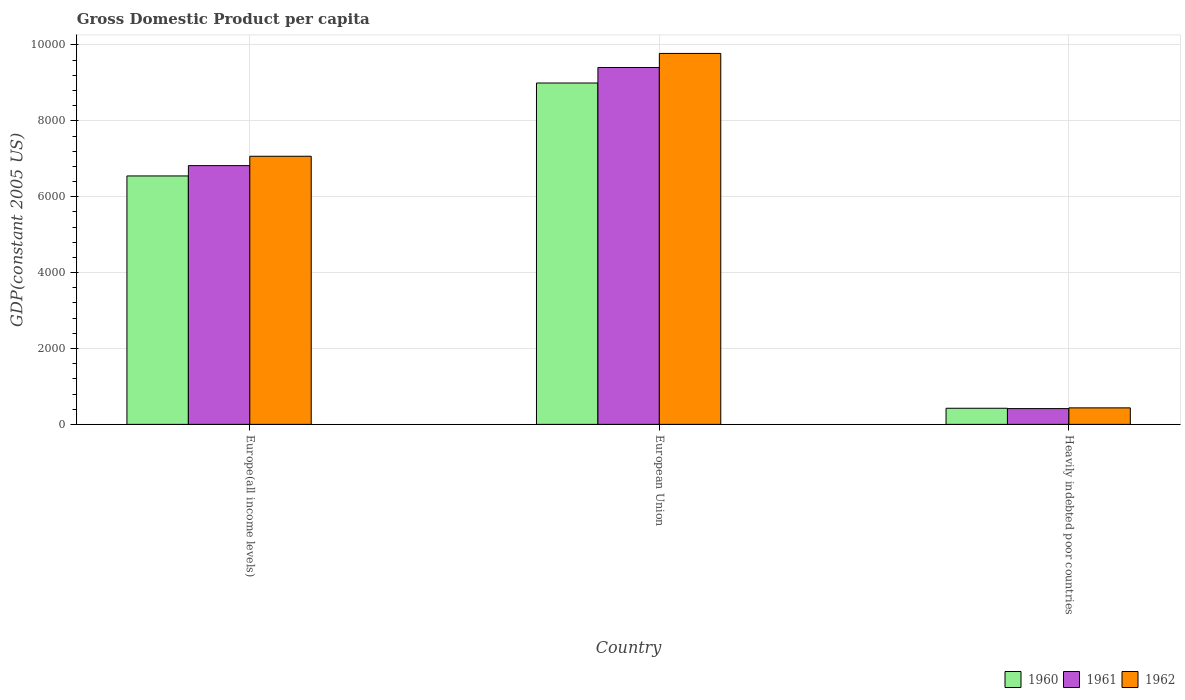Are the number of bars per tick equal to the number of legend labels?
Provide a succinct answer. Yes. Are the number of bars on each tick of the X-axis equal?
Offer a terse response. Yes. How many bars are there on the 1st tick from the left?
Keep it short and to the point. 3. How many bars are there on the 1st tick from the right?
Your response must be concise. 3. What is the label of the 2nd group of bars from the left?
Provide a succinct answer. European Union. In how many cases, is the number of bars for a given country not equal to the number of legend labels?
Offer a terse response. 0. What is the GDP per capita in 1961 in Heavily indebted poor countries?
Keep it short and to the point. 415.63. Across all countries, what is the maximum GDP per capita in 1962?
Offer a very short reply. 9777.3. Across all countries, what is the minimum GDP per capita in 1962?
Offer a very short reply. 435.15. In which country was the GDP per capita in 1962 maximum?
Your answer should be compact. European Union. In which country was the GDP per capita in 1960 minimum?
Offer a very short reply. Heavily indebted poor countries. What is the total GDP per capita in 1962 in the graph?
Provide a short and direct response. 1.73e+04. What is the difference between the GDP per capita in 1960 in European Union and that in Heavily indebted poor countries?
Your response must be concise. 8572.57. What is the difference between the GDP per capita in 1961 in Europe(all income levels) and the GDP per capita in 1960 in European Union?
Give a very brief answer. -2177.67. What is the average GDP per capita in 1960 per country?
Keep it short and to the point. 5323.44. What is the difference between the GDP per capita of/in 1960 and GDP per capita of/in 1961 in European Union?
Give a very brief answer. -408.81. In how many countries, is the GDP per capita in 1961 greater than 400 US$?
Offer a very short reply. 3. What is the ratio of the GDP per capita in 1962 in Europe(all income levels) to that in Heavily indebted poor countries?
Your answer should be very brief. 16.24. Is the GDP per capita in 1960 in Europe(all income levels) less than that in Heavily indebted poor countries?
Your answer should be very brief. No. Is the difference between the GDP per capita in 1960 in European Union and Heavily indebted poor countries greater than the difference between the GDP per capita in 1961 in European Union and Heavily indebted poor countries?
Your response must be concise. No. What is the difference between the highest and the second highest GDP per capita in 1961?
Give a very brief answer. -2586.48. What is the difference between the highest and the lowest GDP per capita in 1962?
Your answer should be very brief. 9342.14. In how many countries, is the GDP per capita in 1961 greater than the average GDP per capita in 1961 taken over all countries?
Keep it short and to the point. 2. What does the 2nd bar from the left in European Union represents?
Offer a terse response. 1961. What does the 3rd bar from the right in Europe(all income levels) represents?
Ensure brevity in your answer.  1960. Are the values on the major ticks of Y-axis written in scientific E-notation?
Offer a very short reply. No. Does the graph contain any zero values?
Your answer should be compact. No. How many legend labels are there?
Ensure brevity in your answer.  3. How are the legend labels stacked?
Provide a short and direct response. Horizontal. What is the title of the graph?
Keep it short and to the point. Gross Domestic Product per capita. Does "2000" appear as one of the legend labels in the graph?
Give a very brief answer. No. What is the label or title of the Y-axis?
Your answer should be very brief. GDP(constant 2005 US). What is the GDP(constant 2005 US) of 1960 in Europe(all income levels)?
Your response must be concise. 6547.96. What is the GDP(constant 2005 US) in 1961 in Europe(all income levels)?
Your answer should be very brief. 6819.79. What is the GDP(constant 2005 US) of 1962 in Europe(all income levels)?
Your answer should be compact. 7066.73. What is the GDP(constant 2005 US) in 1960 in European Union?
Give a very brief answer. 8997.47. What is the GDP(constant 2005 US) of 1961 in European Union?
Your response must be concise. 9406.28. What is the GDP(constant 2005 US) in 1962 in European Union?
Provide a succinct answer. 9777.3. What is the GDP(constant 2005 US) in 1960 in Heavily indebted poor countries?
Offer a terse response. 424.89. What is the GDP(constant 2005 US) of 1961 in Heavily indebted poor countries?
Keep it short and to the point. 415.63. What is the GDP(constant 2005 US) of 1962 in Heavily indebted poor countries?
Ensure brevity in your answer.  435.15. Across all countries, what is the maximum GDP(constant 2005 US) of 1960?
Provide a short and direct response. 8997.47. Across all countries, what is the maximum GDP(constant 2005 US) of 1961?
Provide a succinct answer. 9406.28. Across all countries, what is the maximum GDP(constant 2005 US) in 1962?
Your response must be concise. 9777.3. Across all countries, what is the minimum GDP(constant 2005 US) in 1960?
Offer a terse response. 424.89. Across all countries, what is the minimum GDP(constant 2005 US) in 1961?
Provide a succinct answer. 415.63. Across all countries, what is the minimum GDP(constant 2005 US) of 1962?
Offer a very short reply. 435.15. What is the total GDP(constant 2005 US) in 1960 in the graph?
Your answer should be compact. 1.60e+04. What is the total GDP(constant 2005 US) in 1961 in the graph?
Make the answer very short. 1.66e+04. What is the total GDP(constant 2005 US) of 1962 in the graph?
Give a very brief answer. 1.73e+04. What is the difference between the GDP(constant 2005 US) of 1960 in Europe(all income levels) and that in European Union?
Make the answer very short. -2449.5. What is the difference between the GDP(constant 2005 US) of 1961 in Europe(all income levels) and that in European Union?
Your answer should be compact. -2586.48. What is the difference between the GDP(constant 2005 US) in 1962 in Europe(all income levels) and that in European Union?
Your answer should be compact. -2710.56. What is the difference between the GDP(constant 2005 US) of 1960 in Europe(all income levels) and that in Heavily indebted poor countries?
Provide a short and direct response. 6123.07. What is the difference between the GDP(constant 2005 US) in 1961 in Europe(all income levels) and that in Heavily indebted poor countries?
Your answer should be very brief. 6404.17. What is the difference between the GDP(constant 2005 US) in 1962 in Europe(all income levels) and that in Heavily indebted poor countries?
Your answer should be compact. 6631.58. What is the difference between the GDP(constant 2005 US) of 1960 in European Union and that in Heavily indebted poor countries?
Provide a succinct answer. 8572.57. What is the difference between the GDP(constant 2005 US) of 1961 in European Union and that in Heavily indebted poor countries?
Provide a succinct answer. 8990.65. What is the difference between the GDP(constant 2005 US) in 1962 in European Union and that in Heavily indebted poor countries?
Provide a succinct answer. 9342.14. What is the difference between the GDP(constant 2005 US) in 1960 in Europe(all income levels) and the GDP(constant 2005 US) in 1961 in European Union?
Your response must be concise. -2858.31. What is the difference between the GDP(constant 2005 US) in 1960 in Europe(all income levels) and the GDP(constant 2005 US) in 1962 in European Union?
Provide a short and direct response. -3229.33. What is the difference between the GDP(constant 2005 US) of 1961 in Europe(all income levels) and the GDP(constant 2005 US) of 1962 in European Union?
Ensure brevity in your answer.  -2957.5. What is the difference between the GDP(constant 2005 US) in 1960 in Europe(all income levels) and the GDP(constant 2005 US) in 1961 in Heavily indebted poor countries?
Give a very brief answer. 6132.34. What is the difference between the GDP(constant 2005 US) of 1960 in Europe(all income levels) and the GDP(constant 2005 US) of 1962 in Heavily indebted poor countries?
Offer a terse response. 6112.81. What is the difference between the GDP(constant 2005 US) in 1961 in Europe(all income levels) and the GDP(constant 2005 US) in 1962 in Heavily indebted poor countries?
Ensure brevity in your answer.  6384.64. What is the difference between the GDP(constant 2005 US) in 1960 in European Union and the GDP(constant 2005 US) in 1961 in Heavily indebted poor countries?
Keep it short and to the point. 8581.84. What is the difference between the GDP(constant 2005 US) in 1960 in European Union and the GDP(constant 2005 US) in 1962 in Heavily indebted poor countries?
Your response must be concise. 8562.31. What is the difference between the GDP(constant 2005 US) in 1961 in European Union and the GDP(constant 2005 US) in 1962 in Heavily indebted poor countries?
Your response must be concise. 8971.13. What is the average GDP(constant 2005 US) of 1960 per country?
Keep it short and to the point. 5323.44. What is the average GDP(constant 2005 US) of 1961 per country?
Ensure brevity in your answer.  5547.23. What is the average GDP(constant 2005 US) in 1962 per country?
Your answer should be very brief. 5759.73. What is the difference between the GDP(constant 2005 US) in 1960 and GDP(constant 2005 US) in 1961 in Europe(all income levels)?
Give a very brief answer. -271.83. What is the difference between the GDP(constant 2005 US) of 1960 and GDP(constant 2005 US) of 1962 in Europe(all income levels)?
Provide a succinct answer. -518.77. What is the difference between the GDP(constant 2005 US) of 1961 and GDP(constant 2005 US) of 1962 in Europe(all income levels)?
Your response must be concise. -246.94. What is the difference between the GDP(constant 2005 US) of 1960 and GDP(constant 2005 US) of 1961 in European Union?
Give a very brief answer. -408.81. What is the difference between the GDP(constant 2005 US) of 1960 and GDP(constant 2005 US) of 1962 in European Union?
Your answer should be compact. -779.83. What is the difference between the GDP(constant 2005 US) of 1961 and GDP(constant 2005 US) of 1962 in European Union?
Your answer should be very brief. -371.02. What is the difference between the GDP(constant 2005 US) of 1960 and GDP(constant 2005 US) of 1961 in Heavily indebted poor countries?
Make the answer very short. 9.27. What is the difference between the GDP(constant 2005 US) of 1960 and GDP(constant 2005 US) of 1962 in Heavily indebted poor countries?
Provide a succinct answer. -10.26. What is the difference between the GDP(constant 2005 US) in 1961 and GDP(constant 2005 US) in 1962 in Heavily indebted poor countries?
Your answer should be very brief. -19.53. What is the ratio of the GDP(constant 2005 US) in 1960 in Europe(all income levels) to that in European Union?
Keep it short and to the point. 0.73. What is the ratio of the GDP(constant 2005 US) in 1961 in Europe(all income levels) to that in European Union?
Your response must be concise. 0.72. What is the ratio of the GDP(constant 2005 US) in 1962 in Europe(all income levels) to that in European Union?
Offer a very short reply. 0.72. What is the ratio of the GDP(constant 2005 US) in 1960 in Europe(all income levels) to that in Heavily indebted poor countries?
Provide a succinct answer. 15.41. What is the ratio of the GDP(constant 2005 US) in 1961 in Europe(all income levels) to that in Heavily indebted poor countries?
Provide a short and direct response. 16.41. What is the ratio of the GDP(constant 2005 US) in 1962 in Europe(all income levels) to that in Heavily indebted poor countries?
Offer a terse response. 16.24. What is the ratio of the GDP(constant 2005 US) of 1960 in European Union to that in Heavily indebted poor countries?
Make the answer very short. 21.18. What is the ratio of the GDP(constant 2005 US) of 1961 in European Union to that in Heavily indebted poor countries?
Give a very brief answer. 22.63. What is the ratio of the GDP(constant 2005 US) in 1962 in European Union to that in Heavily indebted poor countries?
Keep it short and to the point. 22.47. What is the difference between the highest and the second highest GDP(constant 2005 US) of 1960?
Provide a succinct answer. 2449.5. What is the difference between the highest and the second highest GDP(constant 2005 US) of 1961?
Provide a succinct answer. 2586.48. What is the difference between the highest and the second highest GDP(constant 2005 US) in 1962?
Provide a short and direct response. 2710.56. What is the difference between the highest and the lowest GDP(constant 2005 US) of 1960?
Your response must be concise. 8572.57. What is the difference between the highest and the lowest GDP(constant 2005 US) of 1961?
Provide a succinct answer. 8990.65. What is the difference between the highest and the lowest GDP(constant 2005 US) of 1962?
Keep it short and to the point. 9342.14. 